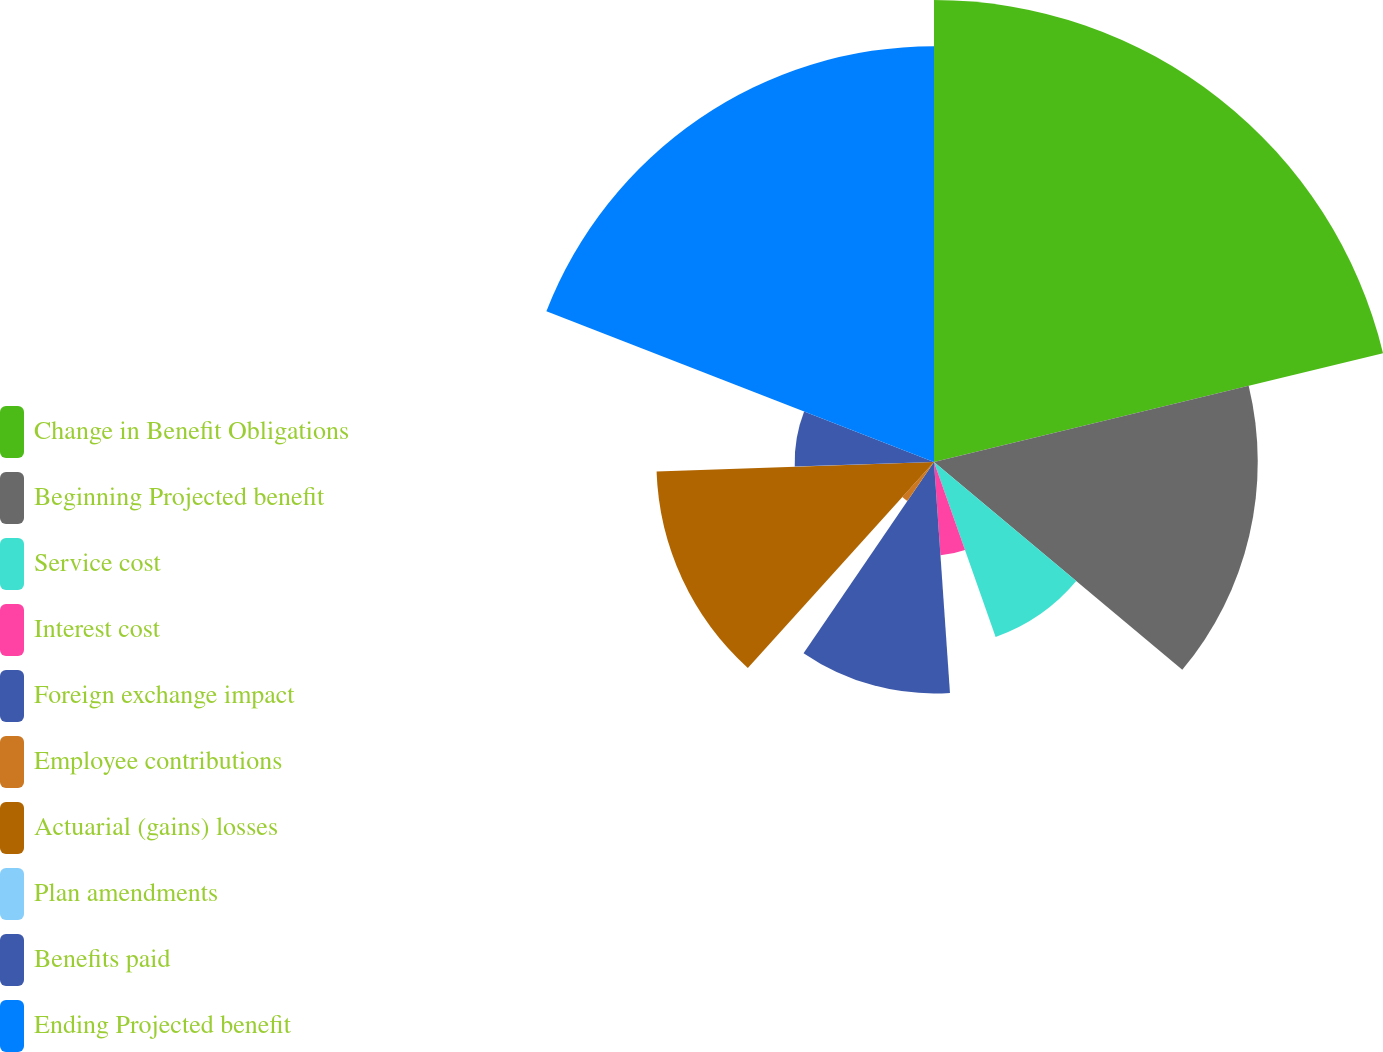Convert chart to OTSL. <chart><loc_0><loc_0><loc_500><loc_500><pie_chart><fcel>Change in Benefit Obligations<fcel>Beginning Projected benefit<fcel>Service cost<fcel>Interest cost<fcel>Foreign exchange impact<fcel>Employee contributions<fcel>Actuarial (gains) losses<fcel>Plan amendments<fcel>Benefits paid<fcel>Ending Projected benefit<nl><fcel>21.22%<fcel>14.87%<fcel>8.52%<fcel>4.29%<fcel>10.63%<fcel>2.17%<fcel>12.75%<fcel>0.05%<fcel>6.4%<fcel>19.1%<nl></chart> 